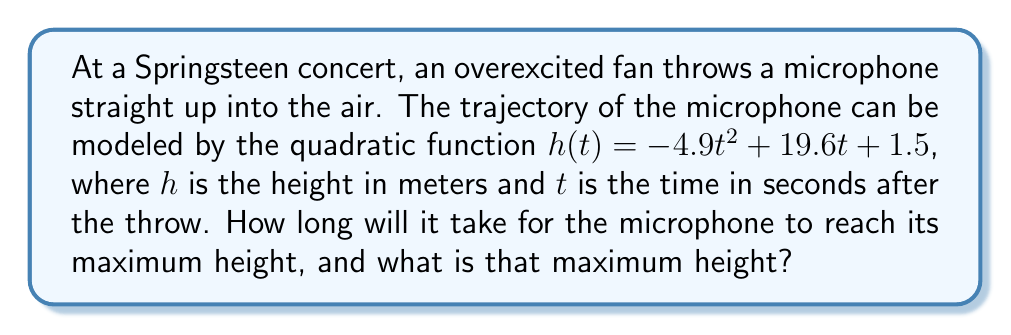Can you answer this question? To solve this problem, we'll follow these steps:

1) The general form of a quadratic function is $f(x) = ax^2 + bx + c$. In this case, we have:
   $h(t) = -4.9t^2 + 19.6t + 1.5$
   
   So, $a = -4.9$, $b = 19.6$, and $c = 1.5$

2) The time to reach maximum height occurs at the vertex of the parabola. For a quadratic function, the x-coordinate of the vertex (in this case, the time) is given by the formula:

   $t = -\frac{b}{2a}$

3) Let's substitute our values:

   $t = -\frac{19.6}{2(-4.9)} = \frac{19.6}{9.8} = 2$ seconds

4) To find the maximum height, we need to substitute this time back into our original function:

   $h(2) = -4.9(2)^2 + 19.6(2) + 1.5$
   
   $= -4.9(4) + 39.2 + 1.5$
   
   $= -19.6 + 39.2 + 1.5$
   
   $= 21.1$ meters

Therefore, the microphone will reach its maximum height after 2 seconds, and that maximum height will be 21.1 meters.
Answer: Time to reach maximum height: 2 seconds
Maximum height: 21.1 meters 